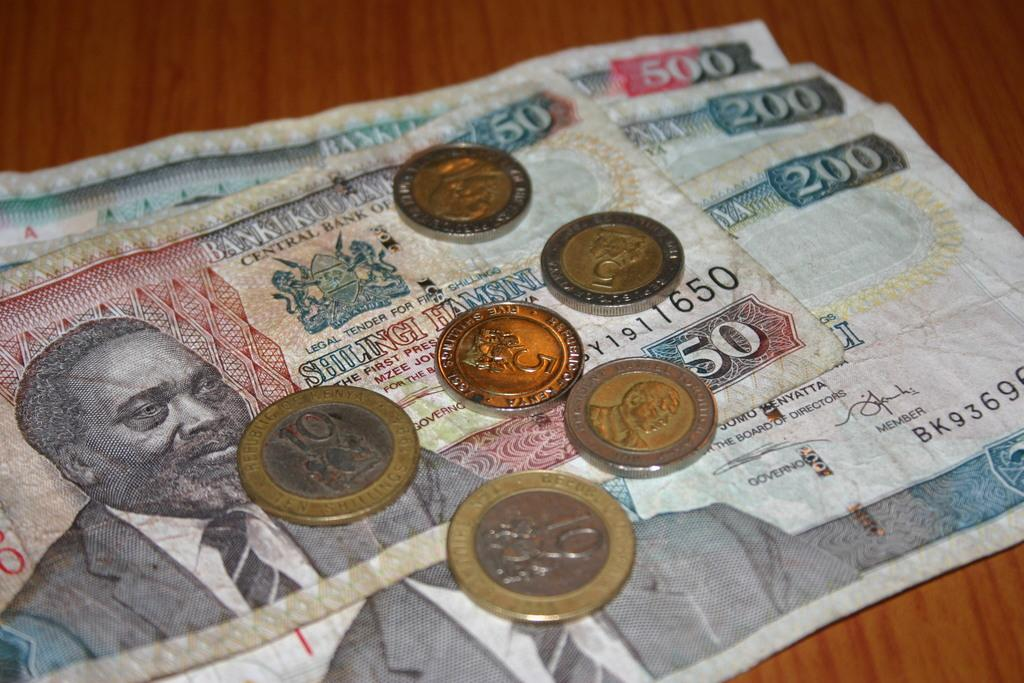<image>
Describe the image concisely. Some coins and several bills of currency ranging from 50 to 500 shillings. 